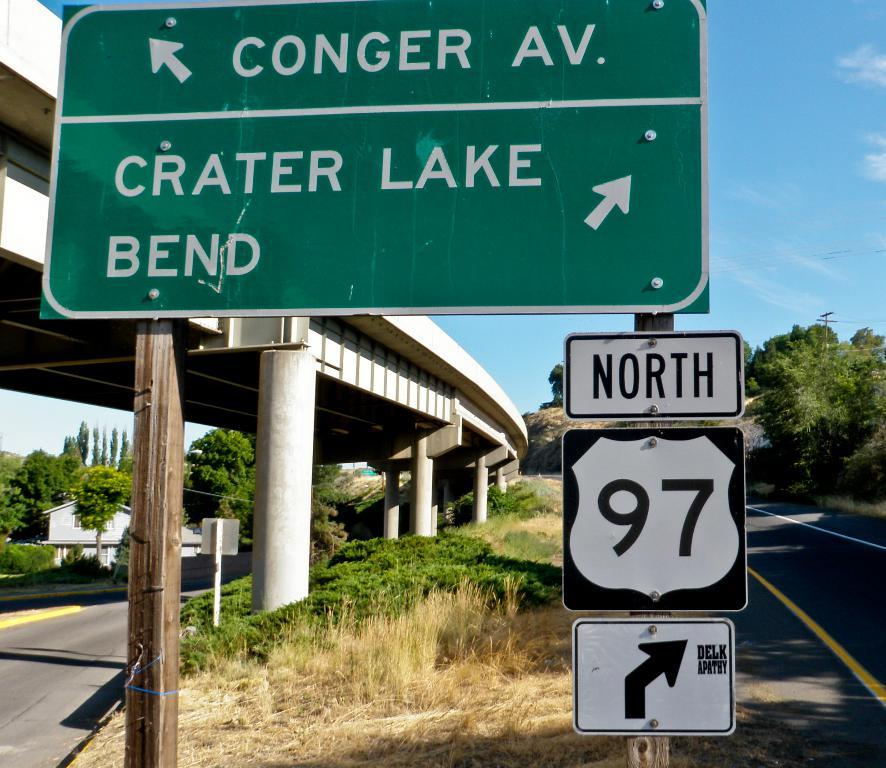<image>
Summarize the visual content of the image. a conger av sign that a north 97 one as well 